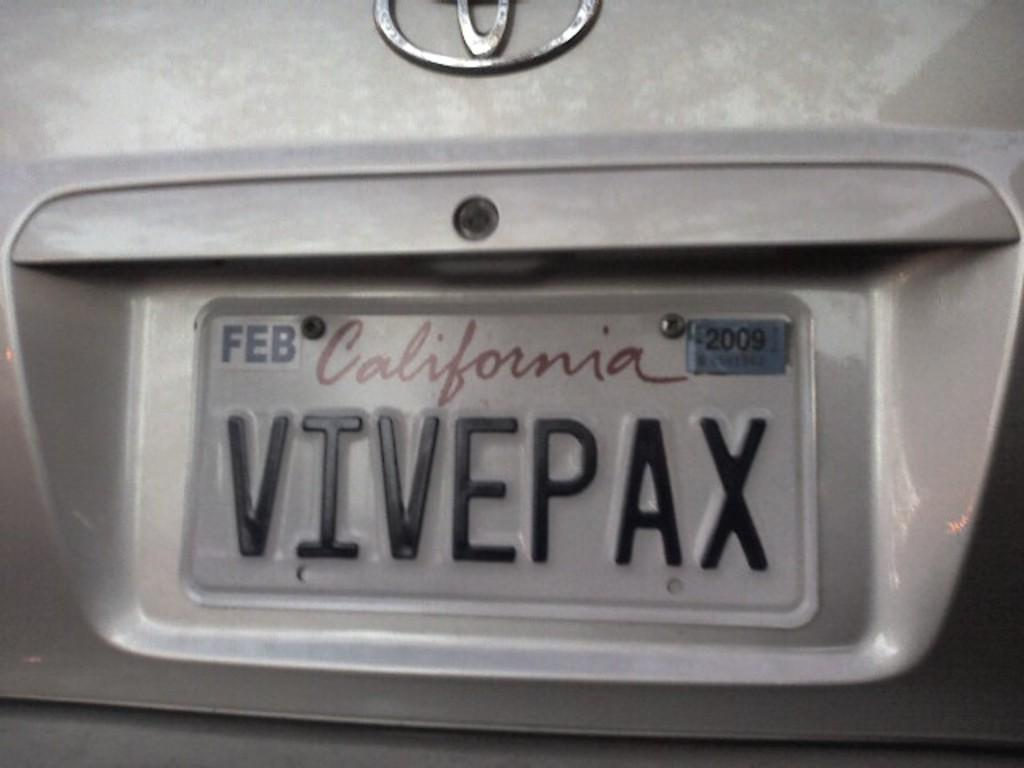<image>
Summarize the visual content of the image. A California license plate VIVEPAX on a Toyota 